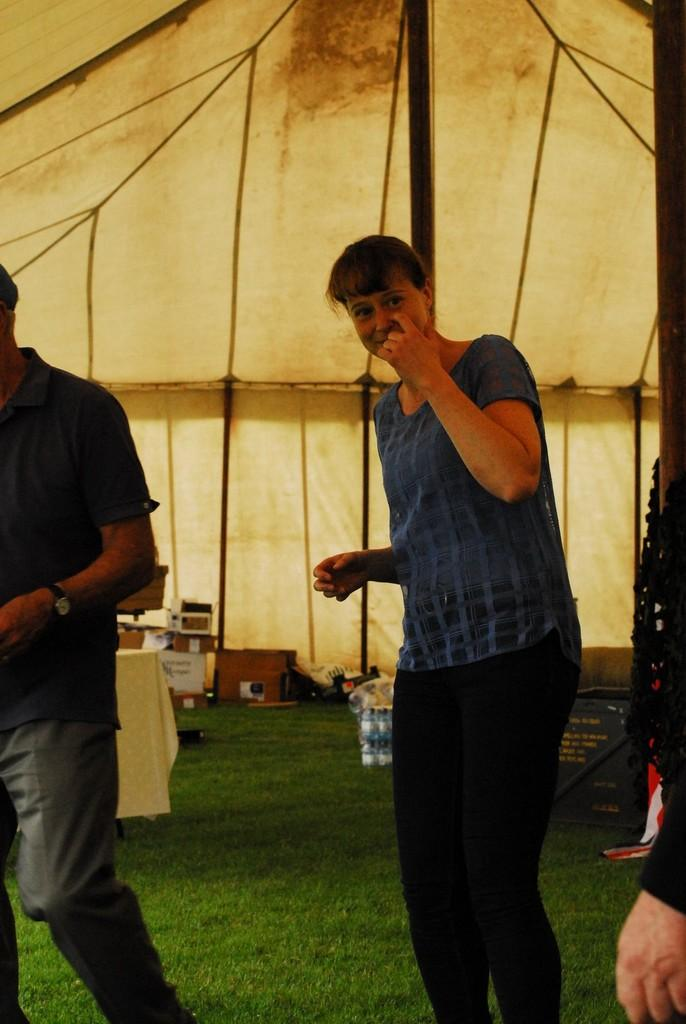What are the people in the image doing? The people in the image are standing under a tent. What can be seen in the background of the image? In the background of the image, there are boards and cardboard boxes. Are there any other objects visible in the background of the image? Yes, there are additional objects visible in the background of the image. Can you see any feathers floating in the air in the image? No, there are no feathers visible in the image. How many minutes does it take for the balloon to inflate in the image? There is no balloon present in the image, so it is not possible to determine how long it would take to inflate. 